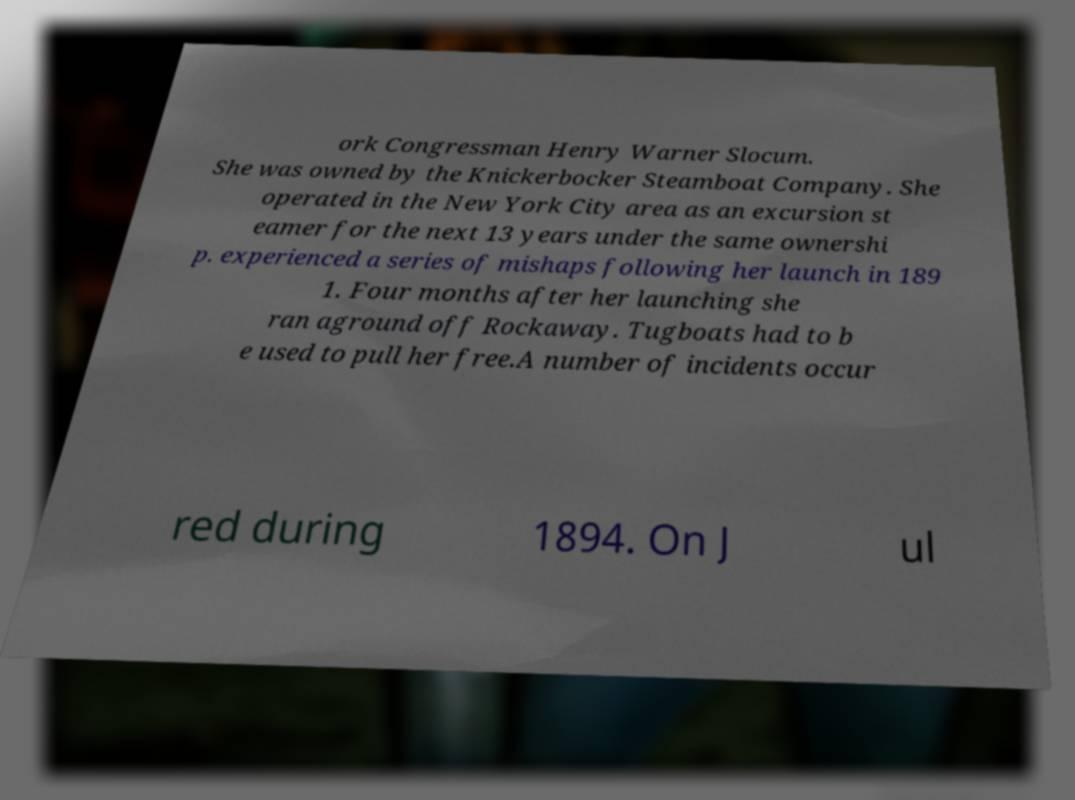Please read and relay the text visible in this image. What does it say? ork Congressman Henry Warner Slocum. She was owned by the Knickerbocker Steamboat Company. She operated in the New York City area as an excursion st eamer for the next 13 years under the same ownershi p. experienced a series of mishaps following her launch in 189 1. Four months after her launching she ran aground off Rockaway. Tugboats had to b e used to pull her free.A number of incidents occur red during 1894. On J ul 